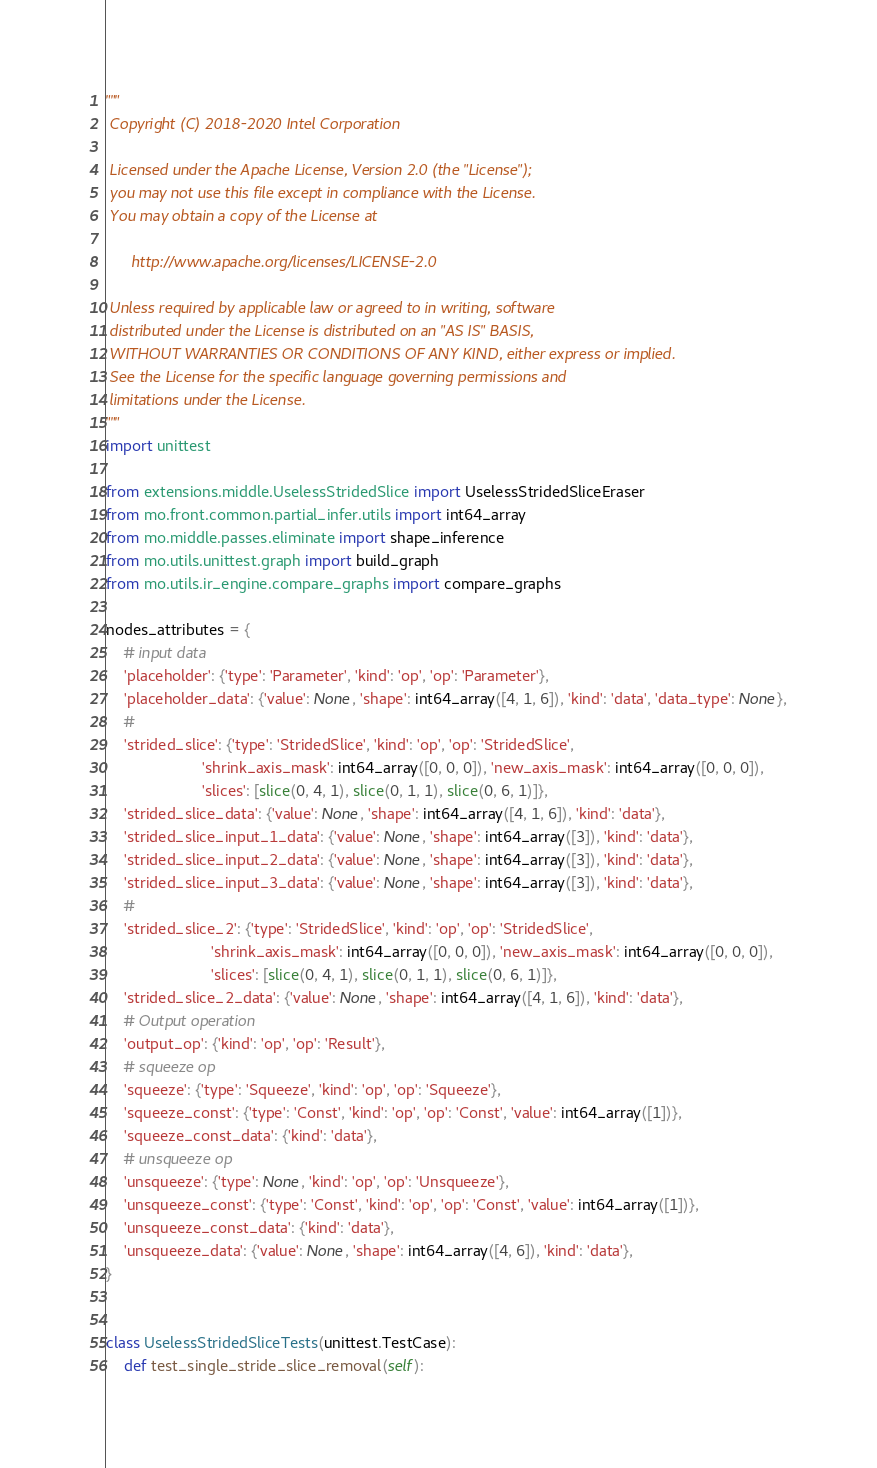<code> <loc_0><loc_0><loc_500><loc_500><_Python_>"""
 Copyright (C) 2018-2020 Intel Corporation

 Licensed under the Apache License, Version 2.0 (the "License");
 you may not use this file except in compliance with the License.
 You may obtain a copy of the License at

      http://www.apache.org/licenses/LICENSE-2.0

 Unless required by applicable law or agreed to in writing, software
 distributed under the License is distributed on an "AS IS" BASIS,
 WITHOUT WARRANTIES OR CONDITIONS OF ANY KIND, either express or implied.
 See the License for the specific language governing permissions and
 limitations under the License.
"""
import unittest

from extensions.middle.UselessStridedSlice import UselessStridedSliceEraser
from mo.front.common.partial_infer.utils import int64_array
from mo.middle.passes.eliminate import shape_inference
from mo.utils.unittest.graph import build_graph
from mo.utils.ir_engine.compare_graphs import compare_graphs

nodes_attributes = {
    # input data
    'placeholder': {'type': 'Parameter', 'kind': 'op', 'op': 'Parameter'},
    'placeholder_data': {'value': None, 'shape': int64_array([4, 1, 6]), 'kind': 'data', 'data_type': None},
    #
    'strided_slice': {'type': 'StridedSlice', 'kind': 'op', 'op': 'StridedSlice',
                      'shrink_axis_mask': int64_array([0, 0, 0]), 'new_axis_mask': int64_array([0, 0, 0]),
                      'slices': [slice(0, 4, 1), slice(0, 1, 1), slice(0, 6, 1)]},
    'strided_slice_data': {'value': None, 'shape': int64_array([4, 1, 6]), 'kind': 'data'},
    'strided_slice_input_1_data': {'value': None, 'shape': int64_array([3]), 'kind': 'data'},
    'strided_slice_input_2_data': {'value': None, 'shape': int64_array([3]), 'kind': 'data'},
    'strided_slice_input_3_data': {'value': None, 'shape': int64_array([3]), 'kind': 'data'},
    #
    'strided_slice_2': {'type': 'StridedSlice', 'kind': 'op', 'op': 'StridedSlice',
                        'shrink_axis_mask': int64_array([0, 0, 0]), 'new_axis_mask': int64_array([0, 0, 0]),
                        'slices': [slice(0, 4, 1), slice(0, 1, 1), slice(0, 6, 1)]},
    'strided_slice_2_data': {'value': None, 'shape': int64_array([4, 1, 6]), 'kind': 'data'},
    # Output operation
    'output_op': {'kind': 'op', 'op': 'Result'},
    # squeeze op
    'squeeze': {'type': 'Squeeze', 'kind': 'op', 'op': 'Squeeze'},
    'squeeze_const': {'type': 'Const', 'kind': 'op', 'op': 'Const', 'value': int64_array([1])},
    'squeeze_const_data': {'kind': 'data'},
    # unsqueeze op
    'unsqueeze': {'type': None, 'kind': 'op', 'op': 'Unsqueeze'},
    'unsqueeze_const': {'type': 'Const', 'kind': 'op', 'op': 'Const', 'value': int64_array([1])},
    'unsqueeze_const_data': {'kind': 'data'},
    'unsqueeze_data': {'value': None, 'shape': int64_array([4, 6]), 'kind': 'data'},
}


class UselessStridedSliceTests(unittest.TestCase):
    def test_single_stride_slice_removal(self):</code> 